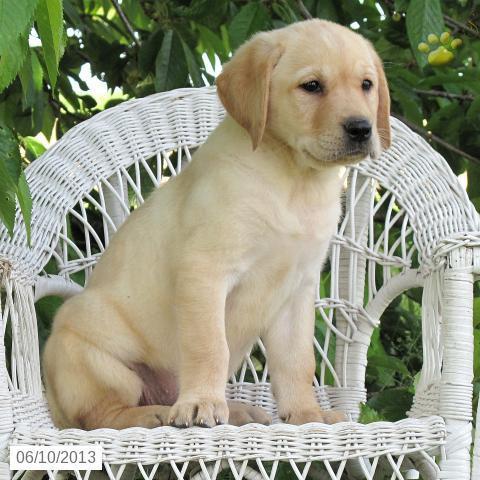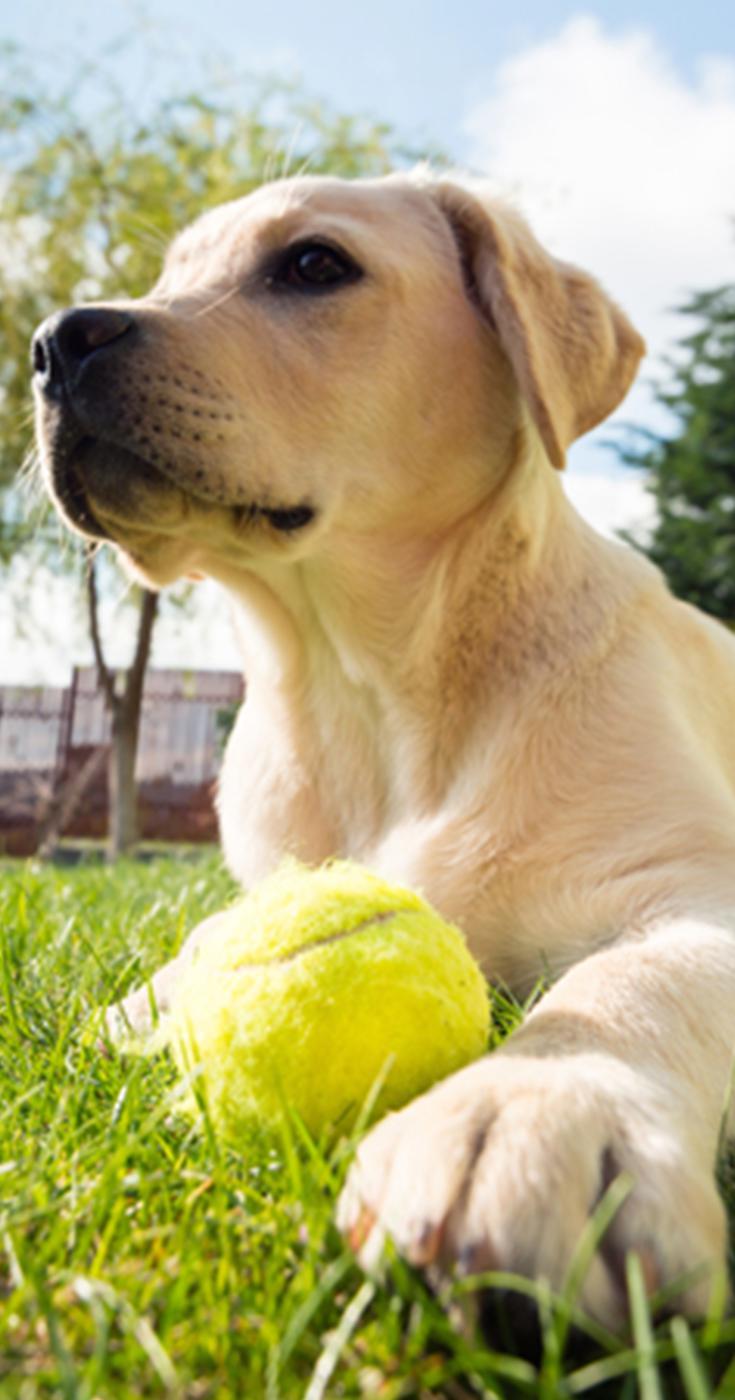The first image is the image on the left, the second image is the image on the right. For the images shown, is this caption "One image shows exactly two retrievers, which are side-by-side." true? Answer yes or no. No. The first image is the image on the left, the second image is the image on the right. For the images displayed, is the sentence "There are two dogs" factually correct? Answer yes or no. Yes. 